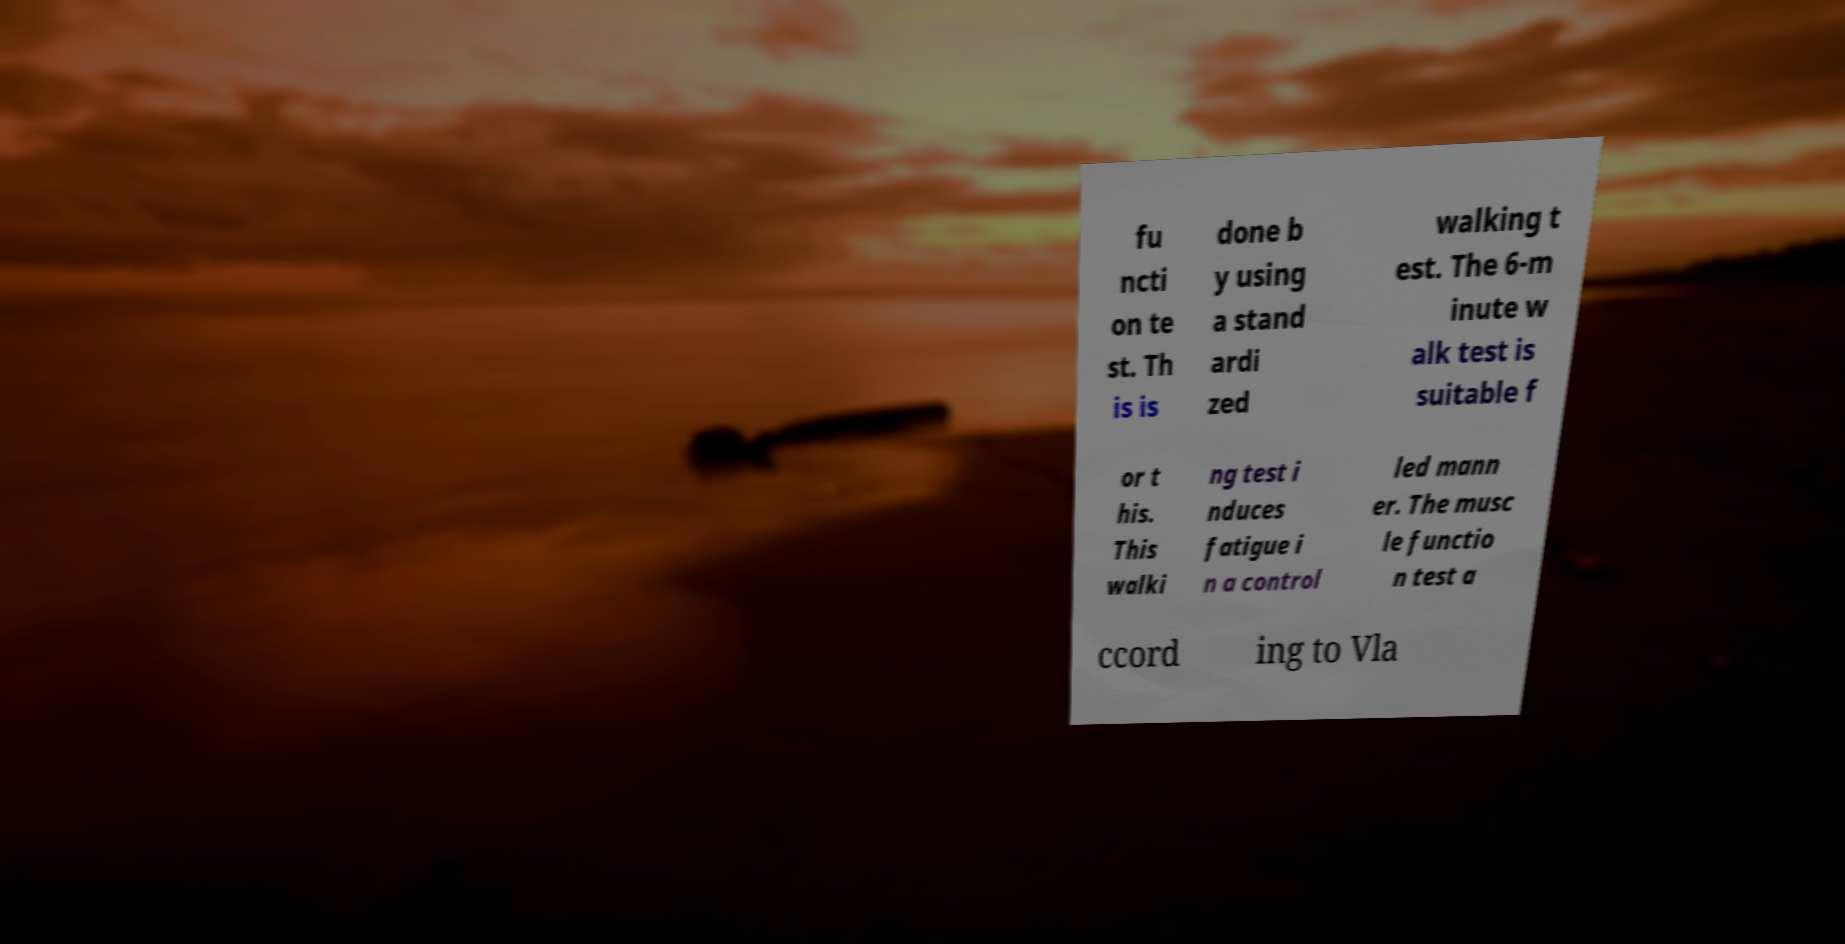What messages or text are displayed in this image? I need them in a readable, typed format. fu ncti on te st. Th is is done b y using a stand ardi zed walking t est. The 6-m inute w alk test is suitable f or t his. This walki ng test i nduces fatigue i n a control led mann er. The musc le functio n test a ccord ing to Vla 